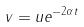Convert formula to latex. <formula><loc_0><loc_0><loc_500><loc_500>v = u e ^ { - 2 \alpha t }</formula> 